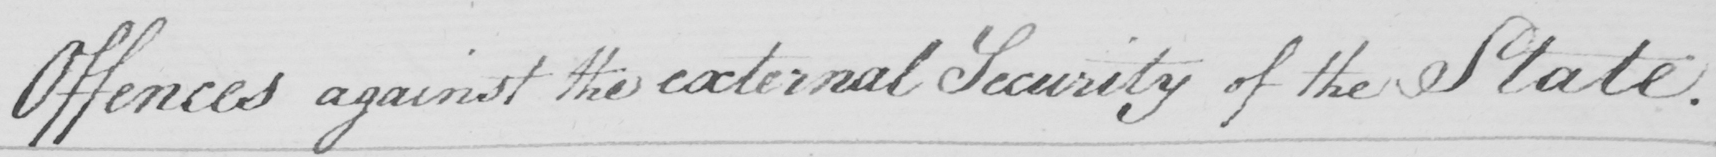What is written in this line of handwriting? Offences against the external Security of the State . 